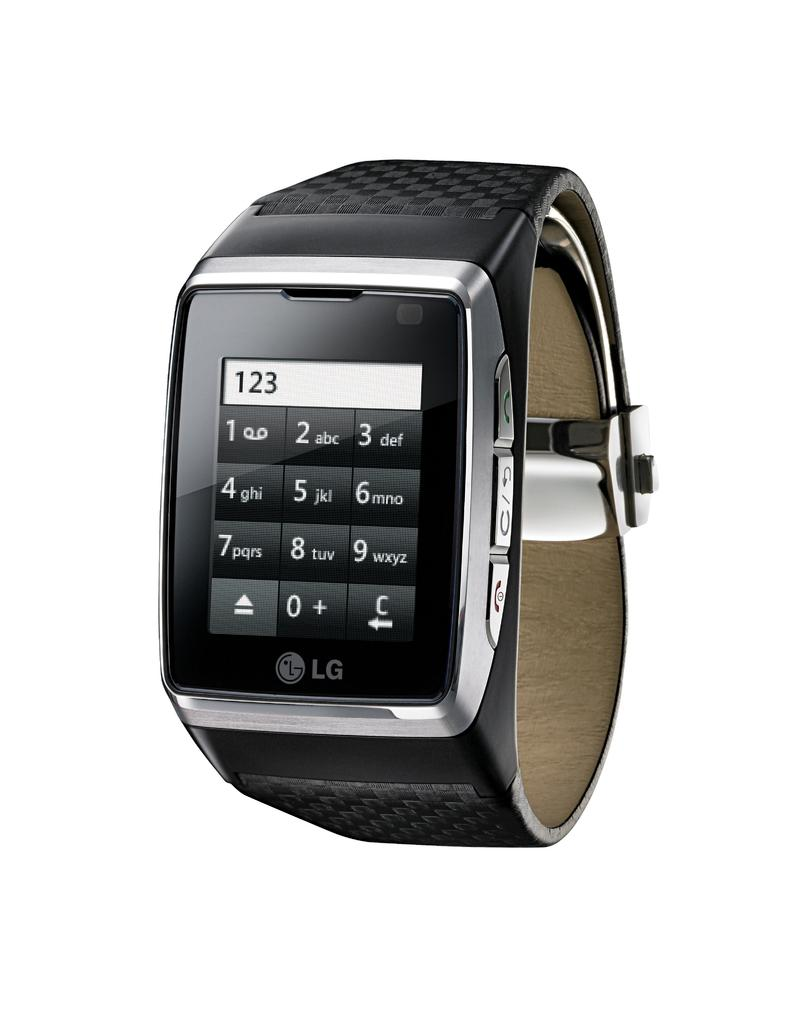<image>
Present a compact description of the photo's key features. An LG watch has a number pad with 123 entered on the face. 